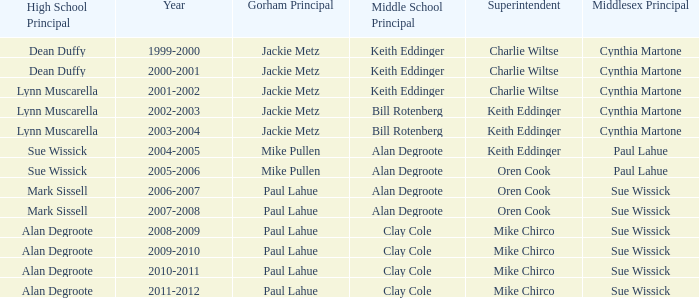During the 2006-2007 school year, with alan degroote as the middle school principal and paul lahue as the gorham principal, who were the superintendent(s)? Oren Cook. 